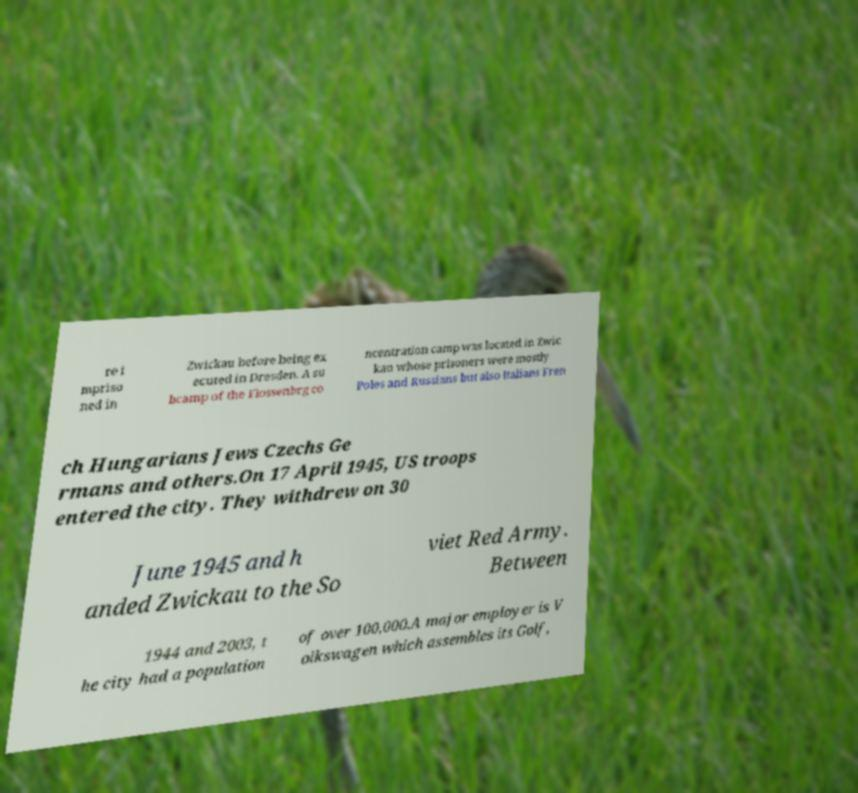Can you accurately transcribe the text from the provided image for me? re i mpriso ned in Zwickau before being ex ecuted in Dresden. A su bcamp of the Flossenbrg co ncentration camp was located in Zwic kau whose prisoners were mostly Poles and Russians but also Italians Fren ch Hungarians Jews Czechs Ge rmans and others.On 17 April 1945, US troops entered the city. They withdrew on 30 June 1945 and h anded Zwickau to the So viet Red Army. Between 1944 and 2003, t he city had a population of over 100,000.A major employer is V olkswagen which assembles its Golf, 